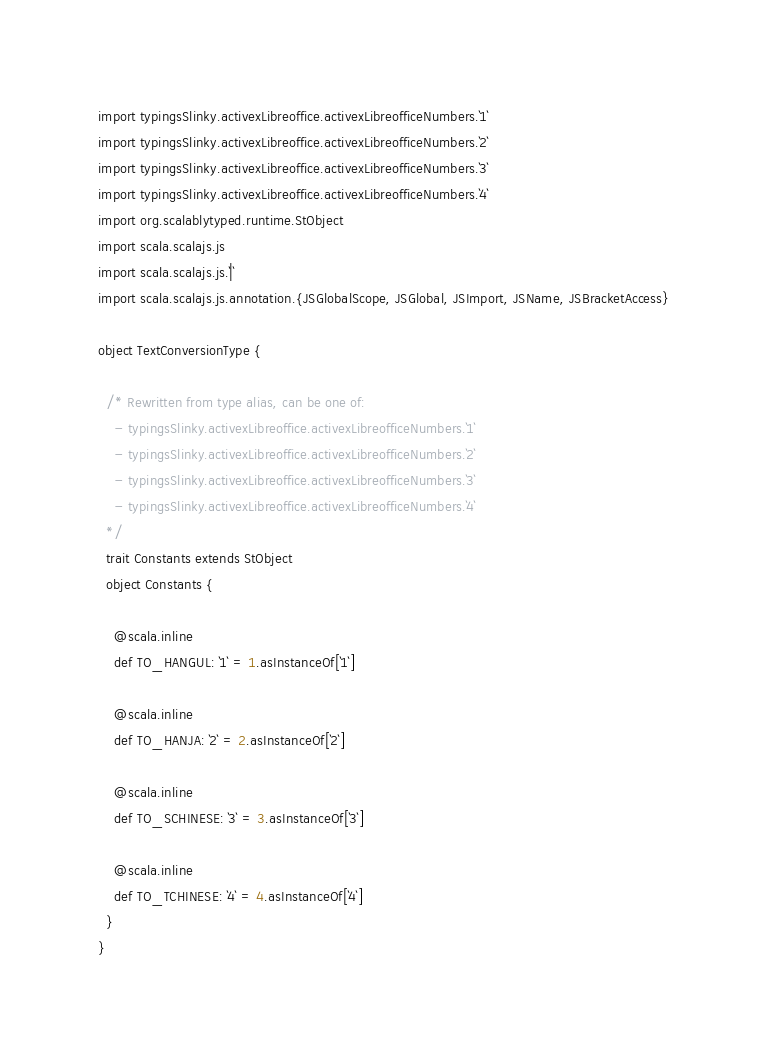Convert code to text. <code><loc_0><loc_0><loc_500><loc_500><_Scala_>
import typingsSlinky.activexLibreoffice.activexLibreofficeNumbers.`1`
import typingsSlinky.activexLibreoffice.activexLibreofficeNumbers.`2`
import typingsSlinky.activexLibreoffice.activexLibreofficeNumbers.`3`
import typingsSlinky.activexLibreoffice.activexLibreofficeNumbers.`4`
import org.scalablytyped.runtime.StObject
import scala.scalajs.js
import scala.scalajs.js.`|`
import scala.scalajs.js.annotation.{JSGlobalScope, JSGlobal, JSImport, JSName, JSBracketAccess}

object TextConversionType {
  
  /* Rewritten from type alias, can be one of: 
    - typingsSlinky.activexLibreoffice.activexLibreofficeNumbers.`1`
    - typingsSlinky.activexLibreoffice.activexLibreofficeNumbers.`2`
    - typingsSlinky.activexLibreoffice.activexLibreofficeNumbers.`3`
    - typingsSlinky.activexLibreoffice.activexLibreofficeNumbers.`4`
  */
  trait Constants extends StObject
  object Constants {
    
    @scala.inline
    def TO_HANGUL: `1` = 1.asInstanceOf[`1`]
    
    @scala.inline
    def TO_HANJA: `2` = 2.asInstanceOf[`2`]
    
    @scala.inline
    def TO_SCHINESE: `3` = 3.asInstanceOf[`3`]
    
    @scala.inline
    def TO_TCHINESE: `4` = 4.asInstanceOf[`4`]
  }
}
</code> 